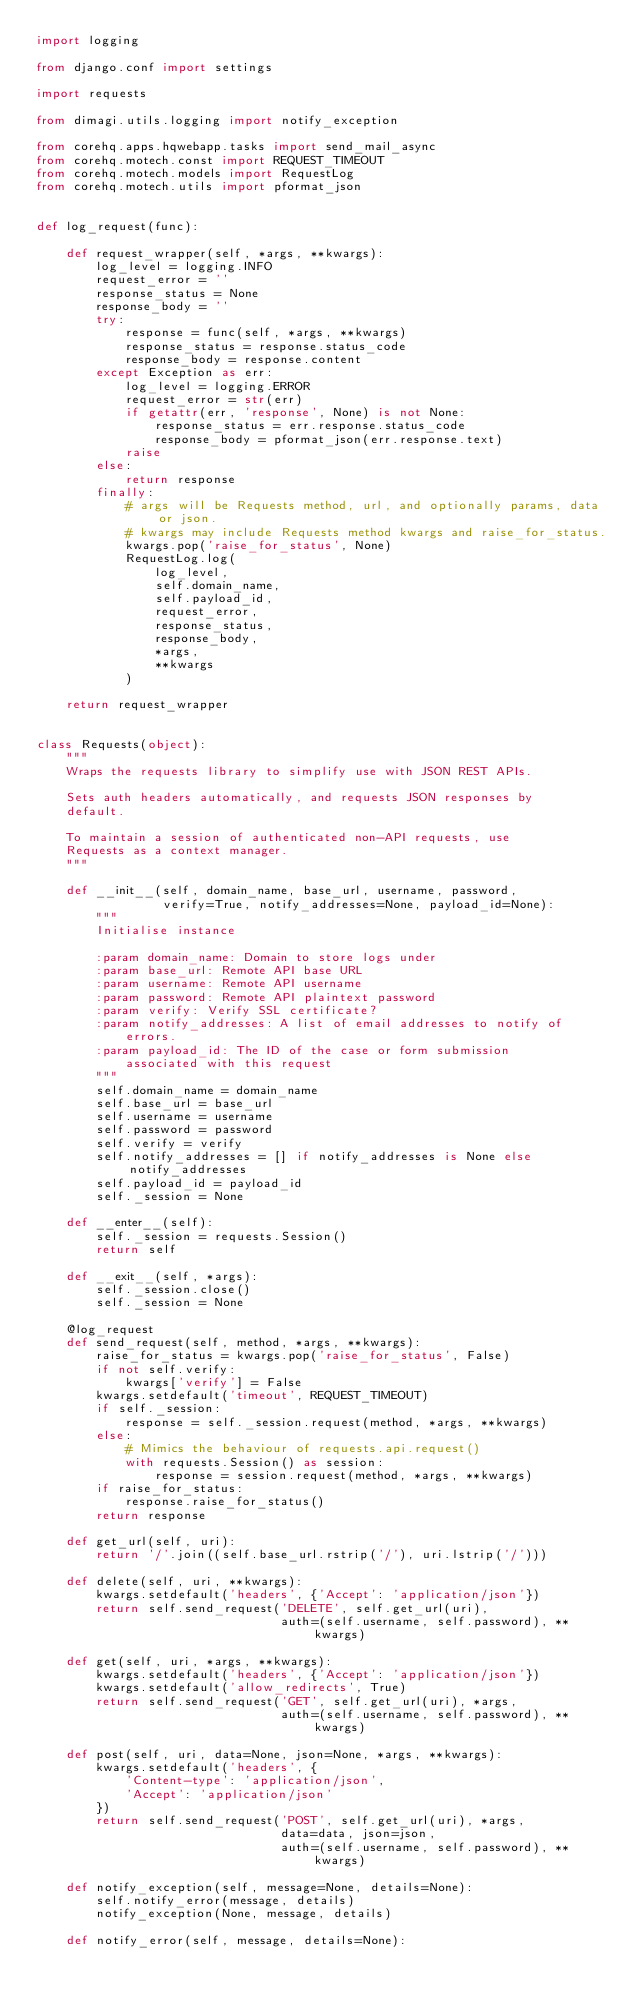Convert code to text. <code><loc_0><loc_0><loc_500><loc_500><_Python_>import logging

from django.conf import settings

import requests

from dimagi.utils.logging import notify_exception

from corehq.apps.hqwebapp.tasks import send_mail_async
from corehq.motech.const import REQUEST_TIMEOUT
from corehq.motech.models import RequestLog
from corehq.motech.utils import pformat_json


def log_request(func):

    def request_wrapper(self, *args, **kwargs):
        log_level = logging.INFO
        request_error = ''
        response_status = None
        response_body = ''
        try:
            response = func(self, *args, **kwargs)
            response_status = response.status_code
            response_body = response.content
        except Exception as err:
            log_level = logging.ERROR
            request_error = str(err)
            if getattr(err, 'response', None) is not None:
                response_status = err.response.status_code
                response_body = pformat_json(err.response.text)
            raise
        else:
            return response
        finally:
            # args will be Requests method, url, and optionally params, data or json.
            # kwargs may include Requests method kwargs and raise_for_status.
            kwargs.pop('raise_for_status', None)
            RequestLog.log(
                log_level,
                self.domain_name,
                self.payload_id,
                request_error,
                response_status,
                response_body,
                *args,
                **kwargs
            )

    return request_wrapper


class Requests(object):
    """
    Wraps the requests library to simplify use with JSON REST APIs.

    Sets auth headers automatically, and requests JSON responses by
    default.

    To maintain a session of authenticated non-API requests, use
    Requests as a context manager.
    """

    def __init__(self, domain_name, base_url, username, password,
                 verify=True, notify_addresses=None, payload_id=None):
        """
        Initialise instance

        :param domain_name: Domain to store logs under
        :param base_url: Remote API base URL
        :param username: Remote API username
        :param password: Remote API plaintext password
        :param verify: Verify SSL certificate?
        :param notify_addresses: A list of email addresses to notify of
            errors.
        :param payload_id: The ID of the case or form submission
            associated with this request
        """
        self.domain_name = domain_name
        self.base_url = base_url
        self.username = username
        self.password = password
        self.verify = verify
        self.notify_addresses = [] if notify_addresses is None else notify_addresses
        self.payload_id = payload_id
        self._session = None

    def __enter__(self):
        self._session = requests.Session()
        return self

    def __exit__(self, *args):
        self._session.close()
        self._session = None

    @log_request
    def send_request(self, method, *args, **kwargs):
        raise_for_status = kwargs.pop('raise_for_status', False)
        if not self.verify:
            kwargs['verify'] = False
        kwargs.setdefault('timeout', REQUEST_TIMEOUT)
        if self._session:
            response = self._session.request(method, *args, **kwargs)
        else:
            # Mimics the behaviour of requests.api.request()
            with requests.Session() as session:
                response = session.request(method, *args, **kwargs)
        if raise_for_status:
            response.raise_for_status()
        return response

    def get_url(self, uri):
        return '/'.join((self.base_url.rstrip('/'), uri.lstrip('/')))

    def delete(self, uri, **kwargs):
        kwargs.setdefault('headers', {'Accept': 'application/json'})
        return self.send_request('DELETE', self.get_url(uri),
                                 auth=(self.username, self.password), **kwargs)

    def get(self, uri, *args, **kwargs):
        kwargs.setdefault('headers', {'Accept': 'application/json'})
        kwargs.setdefault('allow_redirects', True)
        return self.send_request('GET', self.get_url(uri), *args,
                                 auth=(self.username, self.password), **kwargs)

    def post(self, uri, data=None, json=None, *args, **kwargs):
        kwargs.setdefault('headers', {
            'Content-type': 'application/json',
            'Accept': 'application/json'
        })
        return self.send_request('POST', self.get_url(uri), *args,
                                 data=data, json=json,
                                 auth=(self.username, self.password), **kwargs)

    def notify_exception(self, message=None, details=None):
        self.notify_error(message, details)
        notify_exception(None, message, details)

    def notify_error(self, message, details=None):</code> 